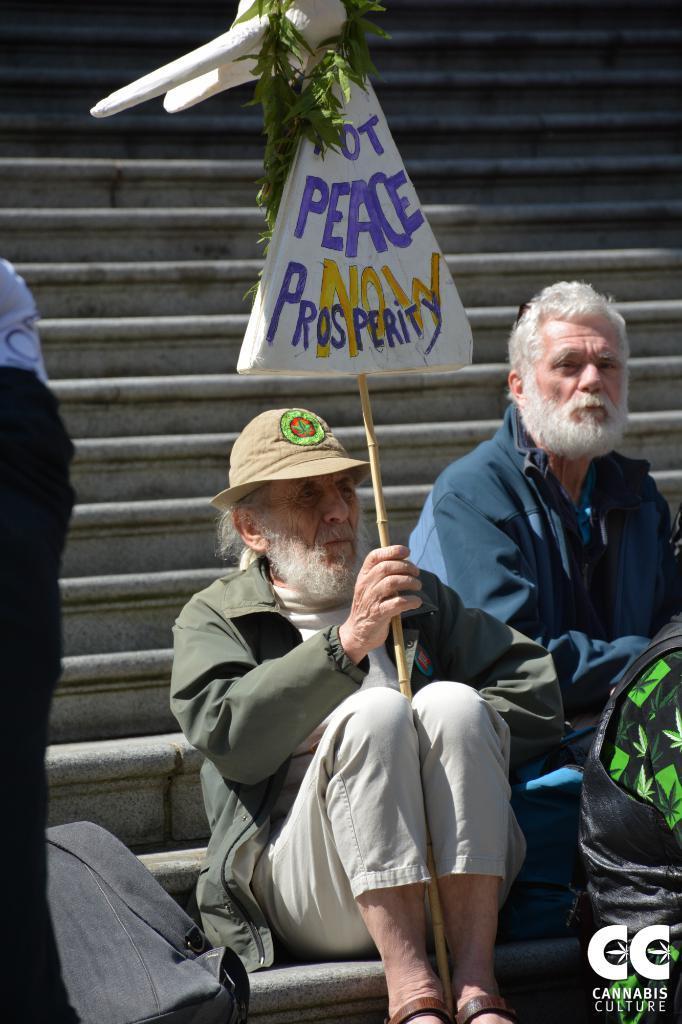How would you summarize this image in a sentence or two? In this image we can see a man sitting on the stairs holding a board with a stick. We can see a garland of leaves to a board. We can also see a bag and a person sitting beside him. 